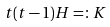<formula> <loc_0><loc_0><loc_500><loc_500>t ( t - 1 ) H = \colon K</formula> 